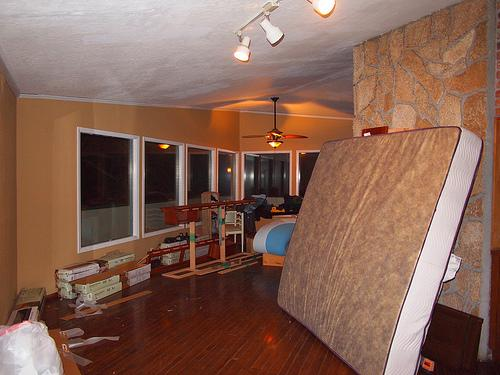Question: when was this picture taken?
Choices:
A. Daytime.
B. Morning.
C. Afternoon.
D. Nighttime.
Answer with the letter. Answer: D Question: how many white lights are on the ceiling?
Choices:
A. 2.
B. 3.
C. 9.
D. 43.
Answer with the letter. Answer: B Question: how many ceiling fans are there?
Choices:
A. 2.
B. 5.
C. 1.
D. 4.
Answer with the letter. Answer: C Question: what is the wall next to the mattress made of?
Choices:
A. Cement.
B. Stone.
C. Paper.
D. Glass.
Answer with the letter. Answer: B Question: how many windows are there?
Choices:
A. 9.
B. 6.
C. 4.
D. 3.
Answer with the letter. Answer: B Question: what color is the back wall?
Choices:
A. Black.
B. White.
C. Brown.
D. Green.
Answer with the letter. Answer: C 